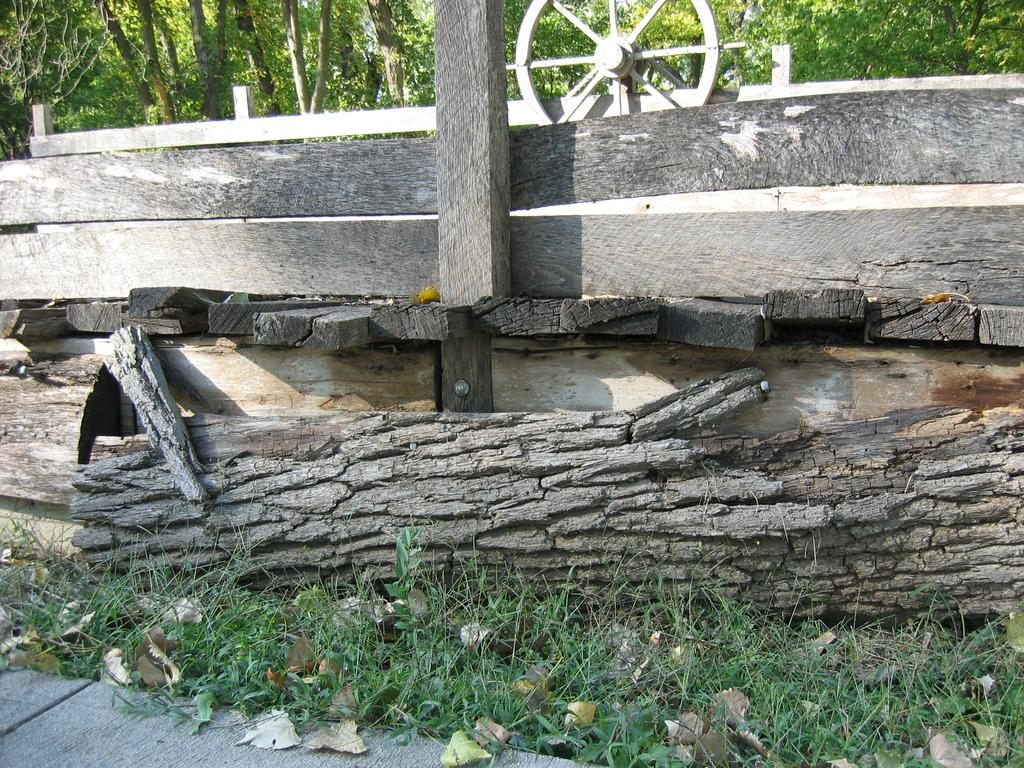What is located on the grass path in the image? There is a tree trunk on a grass path in the image. What can be seen behind the tree trunk? There is a wooden fence and a wheel behind the tree trunk. What type of vegetation is visible in the background? There are trees visible in the background. What type of hook is attached to the tree trunk in the image? There is no hook present in the image; it only features a tree trunk, a wooden fence, a wheel, and trees in the background. 